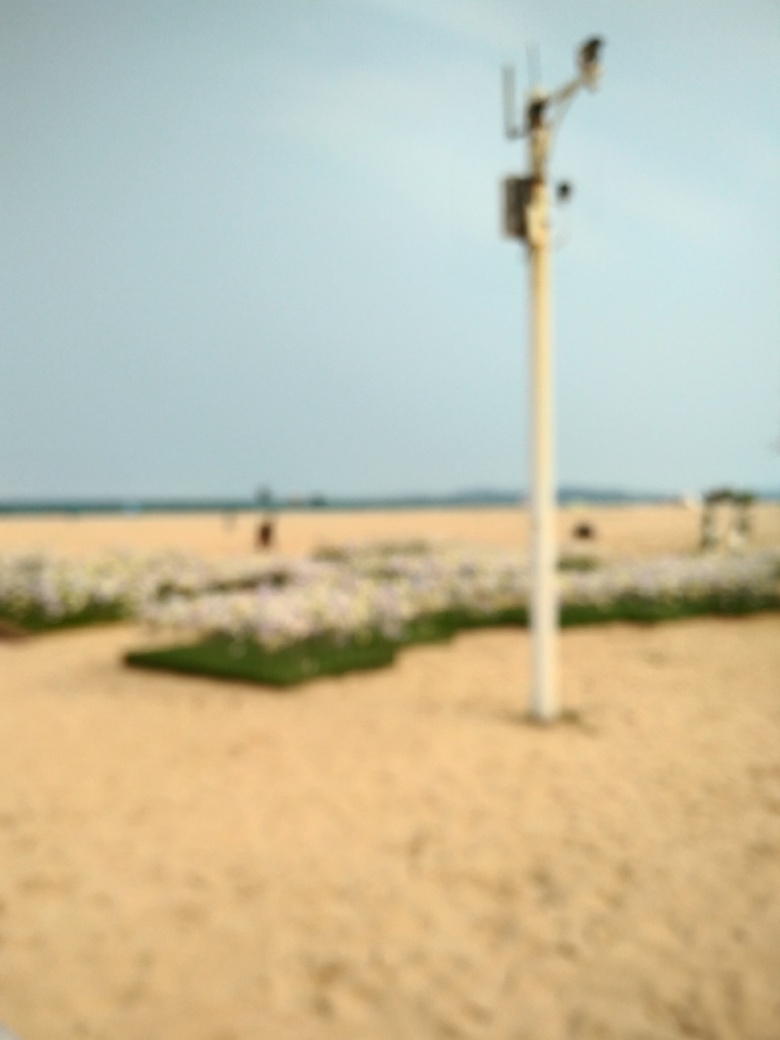Despite the blurriness, can you guess what time of day it is or what the weather might be like? Given the bright and diffuse lighting, it could be inferred that the photo was taken during the day under either cloudy or clear weather conditions. The lack of distinct shadows or overly harsh light might indicate a time when the sun is not at its peak, such as morning or late afternoon. 